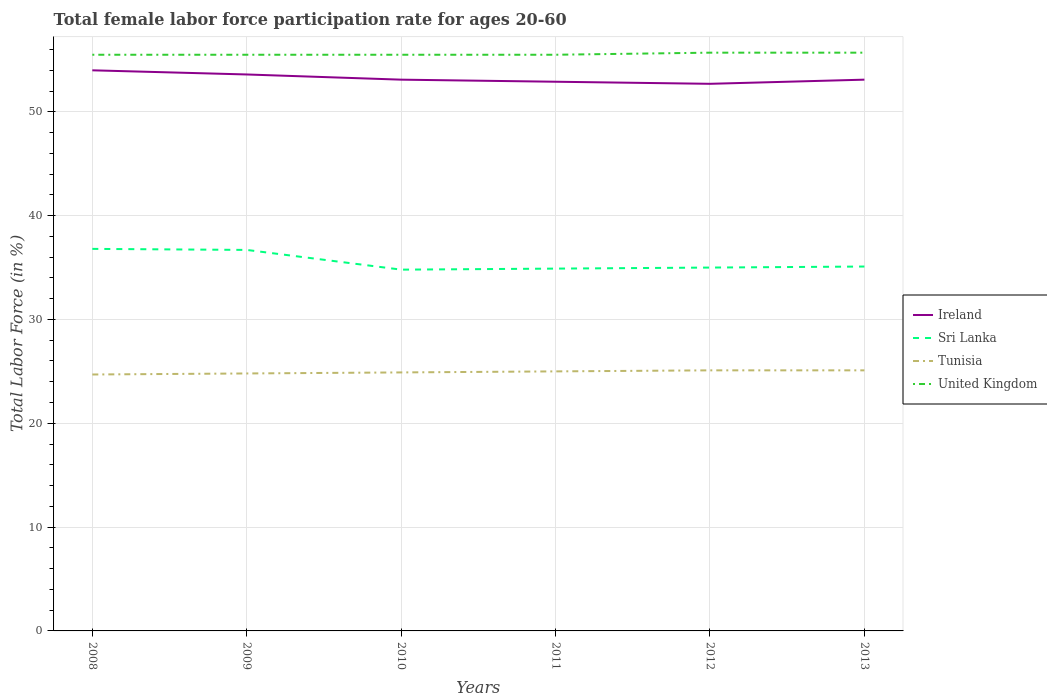Is the number of lines equal to the number of legend labels?
Your response must be concise. Yes. Across all years, what is the maximum female labor force participation rate in Ireland?
Give a very brief answer. 52.7. What is the total female labor force participation rate in Tunisia in the graph?
Offer a very short reply. -0.2. What is the difference between the highest and the second highest female labor force participation rate in Ireland?
Provide a short and direct response. 1.3. What is the difference between the highest and the lowest female labor force participation rate in Tunisia?
Offer a very short reply. 3. Is the female labor force participation rate in United Kingdom strictly greater than the female labor force participation rate in Sri Lanka over the years?
Provide a short and direct response. No. How many years are there in the graph?
Provide a short and direct response. 6. Where does the legend appear in the graph?
Your response must be concise. Center right. What is the title of the graph?
Your answer should be very brief. Total female labor force participation rate for ages 20-60. What is the label or title of the Y-axis?
Offer a very short reply. Total Labor Force (in %). What is the Total Labor Force (in %) in Sri Lanka in 2008?
Your answer should be compact. 36.8. What is the Total Labor Force (in %) in Tunisia in 2008?
Make the answer very short. 24.7. What is the Total Labor Force (in %) of United Kingdom in 2008?
Offer a very short reply. 55.5. What is the Total Labor Force (in %) in Ireland in 2009?
Provide a short and direct response. 53.6. What is the Total Labor Force (in %) in Sri Lanka in 2009?
Your response must be concise. 36.7. What is the Total Labor Force (in %) of Tunisia in 2009?
Keep it short and to the point. 24.8. What is the Total Labor Force (in %) in United Kingdom in 2009?
Your answer should be compact. 55.5. What is the Total Labor Force (in %) of Ireland in 2010?
Your response must be concise. 53.1. What is the Total Labor Force (in %) in Sri Lanka in 2010?
Your answer should be compact. 34.8. What is the Total Labor Force (in %) in Tunisia in 2010?
Make the answer very short. 24.9. What is the Total Labor Force (in %) of United Kingdom in 2010?
Provide a succinct answer. 55.5. What is the Total Labor Force (in %) in Ireland in 2011?
Provide a succinct answer. 52.9. What is the Total Labor Force (in %) in Sri Lanka in 2011?
Give a very brief answer. 34.9. What is the Total Labor Force (in %) in United Kingdom in 2011?
Offer a terse response. 55.5. What is the Total Labor Force (in %) in Ireland in 2012?
Your answer should be compact. 52.7. What is the Total Labor Force (in %) of Tunisia in 2012?
Offer a very short reply. 25.1. What is the Total Labor Force (in %) in United Kingdom in 2012?
Ensure brevity in your answer.  55.7. What is the Total Labor Force (in %) of Ireland in 2013?
Your answer should be compact. 53.1. What is the Total Labor Force (in %) in Sri Lanka in 2013?
Your answer should be compact. 35.1. What is the Total Labor Force (in %) in Tunisia in 2013?
Make the answer very short. 25.1. What is the Total Labor Force (in %) of United Kingdom in 2013?
Offer a very short reply. 55.7. Across all years, what is the maximum Total Labor Force (in %) in Sri Lanka?
Your answer should be very brief. 36.8. Across all years, what is the maximum Total Labor Force (in %) in Tunisia?
Your response must be concise. 25.1. Across all years, what is the maximum Total Labor Force (in %) in United Kingdom?
Provide a short and direct response. 55.7. Across all years, what is the minimum Total Labor Force (in %) of Ireland?
Provide a short and direct response. 52.7. Across all years, what is the minimum Total Labor Force (in %) of Sri Lanka?
Ensure brevity in your answer.  34.8. Across all years, what is the minimum Total Labor Force (in %) of Tunisia?
Ensure brevity in your answer.  24.7. Across all years, what is the minimum Total Labor Force (in %) in United Kingdom?
Ensure brevity in your answer.  55.5. What is the total Total Labor Force (in %) of Ireland in the graph?
Provide a succinct answer. 319.4. What is the total Total Labor Force (in %) of Sri Lanka in the graph?
Make the answer very short. 213.3. What is the total Total Labor Force (in %) in Tunisia in the graph?
Provide a succinct answer. 149.6. What is the total Total Labor Force (in %) in United Kingdom in the graph?
Provide a short and direct response. 333.4. What is the difference between the Total Labor Force (in %) in Sri Lanka in 2008 and that in 2009?
Your answer should be very brief. 0.1. What is the difference between the Total Labor Force (in %) in Ireland in 2008 and that in 2010?
Offer a very short reply. 0.9. What is the difference between the Total Labor Force (in %) in Tunisia in 2008 and that in 2010?
Your response must be concise. -0.2. What is the difference between the Total Labor Force (in %) of Ireland in 2008 and that in 2011?
Give a very brief answer. 1.1. What is the difference between the Total Labor Force (in %) in Sri Lanka in 2008 and that in 2011?
Provide a short and direct response. 1.9. What is the difference between the Total Labor Force (in %) in United Kingdom in 2008 and that in 2011?
Offer a terse response. 0. What is the difference between the Total Labor Force (in %) in Ireland in 2008 and that in 2012?
Offer a terse response. 1.3. What is the difference between the Total Labor Force (in %) in Tunisia in 2008 and that in 2013?
Provide a short and direct response. -0.4. What is the difference between the Total Labor Force (in %) of Ireland in 2009 and that in 2010?
Keep it short and to the point. 0.5. What is the difference between the Total Labor Force (in %) in Sri Lanka in 2009 and that in 2011?
Offer a terse response. 1.8. What is the difference between the Total Labor Force (in %) in United Kingdom in 2009 and that in 2011?
Keep it short and to the point. 0. What is the difference between the Total Labor Force (in %) of Ireland in 2009 and that in 2012?
Your answer should be very brief. 0.9. What is the difference between the Total Labor Force (in %) in United Kingdom in 2009 and that in 2012?
Give a very brief answer. -0.2. What is the difference between the Total Labor Force (in %) in Tunisia in 2009 and that in 2013?
Provide a short and direct response. -0.3. What is the difference between the Total Labor Force (in %) in United Kingdom in 2009 and that in 2013?
Offer a very short reply. -0.2. What is the difference between the Total Labor Force (in %) of Ireland in 2010 and that in 2011?
Make the answer very short. 0.2. What is the difference between the Total Labor Force (in %) of United Kingdom in 2010 and that in 2011?
Keep it short and to the point. 0. What is the difference between the Total Labor Force (in %) of Sri Lanka in 2010 and that in 2012?
Your answer should be compact. -0.2. What is the difference between the Total Labor Force (in %) in Tunisia in 2010 and that in 2012?
Offer a very short reply. -0.2. What is the difference between the Total Labor Force (in %) of Ireland in 2010 and that in 2013?
Keep it short and to the point. 0. What is the difference between the Total Labor Force (in %) of Sri Lanka in 2010 and that in 2013?
Give a very brief answer. -0.3. What is the difference between the Total Labor Force (in %) of United Kingdom in 2010 and that in 2013?
Make the answer very short. -0.2. What is the difference between the Total Labor Force (in %) in Ireland in 2011 and that in 2012?
Provide a short and direct response. 0.2. What is the difference between the Total Labor Force (in %) of Ireland in 2011 and that in 2013?
Keep it short and to the point. -0.2. What is the difference between the Total Labor Force (in %) of United Kingdom in 2011 and that in 2013?
Make the answer very short. -0.2. What is the difference between the Total Labor Force (in %) of Ireland in 2012 and that in 2013?
Keep it short and to the point. -0.4. What is the difference between the Total Labor Force (in %) in Tunisia in 2012 and that in 2013?
Offer a very short reply. 0. What is the difference between the Total Labor Force (in %) of Ireland in 2008 and the Total Labor Force (in %) of Tunisia in 2009?
Ensure brevity in your answer.  29.2. What is the difference between the Total Labor Force (in %) in Ireland in 2008 and the Total Labor Force (in %) in United Kingdom in 2009?
Your response must be concise. -1.5. What is the difference between the Total Labor Force (in %) in Sri Lanka in 2008 and the Total Labor Force (in %) in Tunisia in 2009?
Give a very brief answer. 12. What is the difference between the Total Labor Force (in %) in Sri Lanka in 2008 and the Total Labor Force (in %) in United Kingdom in 2009?
Your answer should be compact. -18.7. What is the difference between the Total Labor Force (in %) in Tunisia in 2008 and the Total Labor Force (in %) in United Kingdom in 2009?
Keep it short and to the point. -30.8. What is the difference between the Total Labor Force (in %) in Ireland in 2008 and the Total Labor Force (in %) in Sri Lanka in 2010?
Provide a succinct answer. 19.2. What is the difference between the Total Labor Force (in %) in Ireland in 2008 and the Total Labor Force (in %) in Tunisia in 2010?
Provide a short and direct response. 29.1. What is the difference between the Total Labor Force (in %) of Sri Lanka in 2008 and the Total Labor Force (in %) of United Kingdom in 2010?
Offer a very short reply. -18.7. What is the difference between the Total Labor Force (in %) of Tunisia in 2008 and the Total Labor Force (in %) of United Kingdom in 2010?
Provide a short and direct response. -30.8. What is the difference between the Total Labor Force (in %) of Ireland in 2008 and the Total Labor Force (in %) of Sri Lanka in 2011?
Your response must be concise. 19.1. What is the difference between the Total Labor Force (in %) of Ireland in 2008 and the Total Labor Force (in %) of United Kingdom in 2011?
Offer a very short reply. -1.5. What is the difference between the Total Labor Force (in %) of Sri Lanka in 2008 and the Total Labor Force (in %) of Tunisia in 2011?
Keep it short and to the point. 11.8. What is the difference between the Total Labor Force (in %) of Sri Lanka in 2008 and the Total Labor Force (in %) of United Kingdom in 2011?
Provide a short and direct response. -18.7. What is the difference between the Total Labor Force (in %) in Tunisia in 2008 and the Total Labor Force (in %) in United Kingdom in 2011?
Provide a succinct answer. -30.8. What is the difference between the Total Labor Force (in %) in Ireland in 2008 and the Total Labor Force (in %) in Sri Lanka in 2012?
Keep it short and to the point. 19. What is the difference between the Total Labor Force (in %) of Ireland in 2008 and the Total Labor Force (in %) of Tunisia in 2012?
Provide a short and direct response. 28.9. What is the difference between the Total Labor Force (in %) of Ireland in 2008 and the Total Labor Force (in %) of United Kingdom in 2012?
Make the answer very short. -1.7. What is the difference between the Total Labor Force (in %) in Sri Lanka in 2008 and the Total Labor Force (in %) in Tunisia in 2012?
Make the answer very short. 11.7. What is the difference between the Total Labor Force (in %) of Sri Lanka in 2008 and the Total Labor Force (in %) of United Kingdom in 2012?
Your answer should be very brief. -18.9. What is the difference between the Total Labor Force (in %) of Tunisia in 2008 and the Total Labor Force (in %) of United Kingdom in 2012?
Provide a succinct answer. -31. What is the difference between the Total Labor Force (in %) in Ireland in 2008 and the Total Labor Force (in %) in Sri Lanka in 2013?
Keep it short and to the point. 18.9. What is the difference between the Total Labor Force (in %) of Ireland in 2008 and the Total Labor Force (in %) of Tunisia in 2013?
Keep it short and to the point. 28.9. What is the difference between the Total Labor Force (in %) in Sri Lanka in 2008 and the Total Labor Force (in %) in Tunisia in 2013?
Offer a very short reply. 11.7. What is the difference between the Total Labor Force (in %) of Sri Lanka in 2008 and the Total Labor Force (in %) of United Kingdom in 2013?
Your response must be concise. -18.9. What is the difference between the Total Labor Force (in %) in Tunisia in 2008 and the Total Labor Force (in %) in United Kingdom in 2013?
Your response must be concise. -31. What is the difference between the Total Labor Force (in %) of Ireland in 2009 and the Total Labor Force (in %) of Sri Lanka in 2010?
Make the answer very short. 18.8. What is the difference between the Total Labor Force (in %) of Ireland in 2009 and the Total Labor Force (in %) of Tunisia in 2010?
Make the answer very short. 28.7. What is the difference between the Total Labor Force (in %) of Sri Lanka in 2009 and the Total Labor Force (in %) of United Kingdom in 2010?
Ensure brevity in your answer.  -18.8. What is the difference between the Total Labor Force (in %) in Tunisia in 2009 and the Total Labor Force (in %) in United Kingdom in 2010?
Make the answer very short. -30.7. What is the difference between the Total Labor Force (in %) in Ireland in 2009 and the Total Labor Force (in %) in Tunisia in 2011?
Ensure brevity in your answer.  28.6. What is the difference between the Total Labor Force (in %) in Sri Lanka in 2009 and the Total Labor Force (in %) in Tunisia in 2011?
Your answer should be very brief. 11.7. What is the difference between the Total Labor Force (in %) of Sri Lanka in 2009 and the Total Labor Force (in %) of United Kingdom in 2011?
Ensure brevity in your answer.  -18.8. What is the difference between the Total Labor Force (in %) in Tunisia in 2009 and the Total Labor Force (in %) in United Kingdom in 2011?
Give a very brief answer. -30.7. What is the difference between the Total Labor Force (in %) in Ireland in 2009 and the Total Labor Force (in %) in Sri Lanka in 2012?
Provide a short and direct response. 18.6. What is the difference between the Total Labor Force (in %) of Ireland in 2009 and the Total Labor Force (in %) of Tunisia in 2012?
Provide a succinct answer. 28.5. What is the difference between the Total Labor Force (in %) of Ireland in 2009 and the Total Labor Force (in %) of United Kingdom in 2012?
Offer a terse response. -2.1. What is the difference between the Total Labor Force (in %) of Sri Lanka in 2009 and the Total Labor Force (in %) of Tunisia in 2012?
Your response must be concise. 11.6. What is the difference between the Total Labor Force (in %) in Sri Lanka in 2009 and the Total Labor Force (in %) in United Kingdom in 2012?
Ensure brevity in your answer.  -19. What is the difference between the Total Labor Force (in %) in Tunisia in 2009 and the Total Labor Force (in %) in United Kingdom in 2012?
Provide a short and direct response. -30.9. What is the difference between the Total Labor Force (in %) in Ireland in 2009 and the Total Labor Force (in %) in Sri Lanka in 2013?
Make the answer very short. 18.5. What is the difference between the Total Labor Force (in %) in Sri Lanka in 2009 and the Total Labor Force (in %) in United Kingdom in 2013?
Offer a terse response. -19. What is the difference between the Total Labor Force (in %) in Tunisia in 2009 and the Total Labor Force (in %) in United Kingdom in 2013?
Offer a terse response. -30.9. What is the difference between the Total Labor Force (in %) of Ireland in 2010 and the Total Labor Force (in %) of Tunisia in 2011?
Provide a short and direct response. 28.1. What is the difference between the Total Labor Force (in %) of Sri Lanka in 2010 and the Total Labor Force (in %) of United Kingdom in 2011?
Your answer should be compact. -20.7. What is the difference between the Total Labor Force (in %) of Tunisia in 2010 and the Total Labor Force (in %) of United Kingdom in 2011?
Make the answer very short. -30.6. What is the difference between the Total Labor Force (in %) of Sri Lanka in 2010 and the Total Labor Force (in %) of United Kingdom in 2012?
Provide a short and direct response. -20.9. What is the difference between the Total Labor Force (in %) in Tunisia in 2010 and the Total Labor Force (in %) in United Kingdom in 2012?
Provide a short and direct response. -30.8. What is the difference between the Total Labor Force (in %) of Ireland in 2010 and the Total Labor Force (in %) of Sri Lanka in 2013?
Make the answer very short. 18. What is the difference between the Total Labor Force (in %) of Ireland in 2010 and the Total Labor Force (in %) of Tunisia in 2013?
Ensure brevity in your answer.  28. What is the difference between the Total Labor Force (in %) of Sri Lanka in 2010 and the Total Labor Force (in %) of United Kingdom in 2013?
Make the answer very short. -20.9. What is the difference between the Total Labor Force (in %) of Tunisia in 2010 and the Total Labor Force (in %) of United Kingdom in 2013?
Ensure brevity in your answer.  -30.8. What is the difference between the Total Labor Force (in %) of Ireland in 2011 and the Total Labor Force (in %) of Sri Lanka in 2012?
Provide a succinct answer. 17.9. What is the difference between the Total Labor Force (in %) of Ireland in 2011 and the Total Labor Force (in %) of Tunisia in 2012?
Provide a succinct answer. 27.8. What is the difference between the Total Labor Force (in %) in Ireland in 2011 and the Total Labor Force (in %) in United Kingdom in 2012?
Give a very brief answer. -2.8. What is the difference between the Total Labor Force (in %) in Sri Lanka in 2011 and the Total Labor Force (in %) in Tunisia in 2012?
Offer a terse response. 9.8. What is the difference between the Total Labor Force (in %) in Sri Lanka in 2011 and the Total Labor Force (in %) in United Kingdom in 2012?
Make the answer very short. -20.8. What is the difference between the Total Labor Force (in %) in Tunisia in 2011 and the Total Labor Force (in %) in United Kingdom in 2012?
Make the answer very short. -30.7. What is the difference between the Total Labor Force (in %) of Ireland in 2011 and the Total Labor Force (in %) of Tunisia in 2013?
Offer a terse response. 27.8. What is the difference between the Total Labor Force (in %) of Ireland in 2011 and the Total Labor Force (in %) of United Kingdom in 2013?
Keep it short and to the point. -2.8. What is the difference between the Total Labor Force (in %) of Sri Lanka in 2011 and the Total Labor Force (in %) of United Kingdom in 2013?
Make the answer very short. -20.8. What is the difference between the Total Labor Force (in %) of Tunisia in 2011 and the Total Labor Force (in %) of United Kingdom in 2013?
Offer a terse response. -30.7. What is the difference between the Total Labor Force (in %) of Ireland in 2012 and the Total Labor Force (in %) of Sri Lanka in 2013?
Offer a very short reply. 17.6. What is the difference between the Total Labor Force (in %) of Ireland in 2012 and the Total Labor Force (in %) of Tunisia in 2013?
Provide a succinct answer. 27.6. What is the difference between the Total Labor Force (in %) of Ireland in 2012 and the Total Labor Force (in %) of United Kingdom in 2013?
Offer a very short reply. -3. What is the difference between the Total Labor Force (in %) of Sri Lanka in 2012 and the Total Labor Force (in %) of United Kingdom in 2013?
Make the answer very short. -20.7. What is the difference between the Total Labor Force (in %) in Tunisia in 2012 and the Total Labor Force (in %) in United Kingdom in 2013?
Ensure brevity in your answer.  -30.6. What is the average Total Labor Force (in %) in Ireland per year?
Offer a terse response. 53.23. What is the average Total Labor Force (in %) in Sri Lanka per year?
Give a very brief answer. 35.55. What is the average Total Labor Force (in %) in Tunisia per year?
Provide a short and direct response. 24.93. What is the average Total Labor Force (in %) of United Kingdom per year?
Provide a succinct answer. 55.57. In the year 2008, what is the difference between the Total Labor Force (in %) of Ireland and Total Labor Force (in %) of Tunisia?
Keep it short and to the point. 29.3. In the year 2008, what is the difference between the Total Labor Force (in %) in Sri Lanka and Total Labor Force (in %) in United Kingdom?
Provide a short and direct response. -18.7. In the year 2008, what is the difference between the Total Labor Force (in %) in Tunisia and Total Labor Force (in %) in United Kingdom?
Provide a short and direct response. -30.8. In the year 2009, what is the difference between the Total Labor Force (in %) of Ireland and Total Labor Force (in %) of Sri Lanka?
Provide a succinct answer. 16.9. In the year 2009, what is the difference between the Total Labor Force (in %) in Ireland and Total Labor Force (in %) in Tunisia?
Your answer should be very brief. 28.8. In the year 2009, what is the difference between the Total Labor Force (in %) in Sri Lanka and Total Labor Force (in %) in Tunisia?
Offer a very short reply. 11.9. In the year 2009, what is the difference between the Total Labor Force (in %) in Sri Lanka and Total Labor Force (in %) in United Kingdom?
Provide a succinct answer. -18.8. In the year 2009, what is the difference between the Total Labor Force (in %) in Tunisia and Total Labor Force (in %) in United Kingdom?
Your answer should be compact. -30.7. In the year 2010, what is the difference between the Total Labor Force (in %) of Ireland and Total Labor Force (in %) of Tunisia?
Your answer should be very brief. 28.2. In the year 2010, what is the difference between the Total Labor Force (in %) of Sri Lanka and Total Labor Force (in %) of Tunisia?
Your answer should be very brief. 9.9. In the year 2010, what is the difference between the Total Labor Force (in %) of Sri Lanka and Total Labor Force (in %) of United Kingdom?
Your response must be concise. -20.7. In the year 2010, what is the difference between the Total Labor Force (in %) of Tunisia and Total Labor Force (in %) of United Kingdom?
Provide a succinct answer. -30.6. In the year 2011, what is the difference between the Total Labor Force (in %) of Ireland and Total Labor Force (in %) of Sri Lanka?
Your answer should be compact. 18. In the year 2011, what is the difference between the Total Labor Force (in %) in Ireland and Total Labor Force (in %) in Tunisia?
Your answer should be very brief. 27.9. In the year 2011, what is the difference between the Total Labor Force (in %) of Sri Lanka and Total Labor Force (in %) of United Kingdom?
Make the answer very short. -20.6. In the year 2011, what is the difference between the Total Labor Force (in %) in Tunisia and Total Labor Force (in %) in United Kingdom?
Keep it short and to the point. -30.5. In the year 2012, what is the difference between the Total Labor Force (in %) of Ireland and Total Labor Force (in %) of Tunisia?
Provide a short and direct response. 27.6. In the year 2012, what is the difference between the Total Labor Force (in %) in Ireland and Total Labor Force (in %) in United Kingdom?
Give a very brief answer. -3. In the year 2012, what is the difference between the Total Labor Force (in %) of Sri Lanka and Total Labor Force (in %) of Tunisia?
Ensure brevity in your answer.  9.9. In the year 2012, what is the difference between the Total Labor Force (in %) in Sri Lanka and Total Labor Force (in %) in United Kingdom?
Your answer should be compact. -20.7. In the year 2012, what is the difference between the Total Labor Force (in %) in Tunisia and Total Labor Force (in %) in United Kingdom?
Give a very brief answer. -30.6. In the year 2013, what is the difference between the Total Labor Force (in %) of Ireland and Total Labor Force (in %) of Sri Lanka?
Your response must be concise. 18. In the year 2013, what is the difference between the Total Labor Force (in %) in Ireland and Total Labor Force (in %) in Tunisia?
Keep it short and to the point. 28. In the year 2013, what is the difference between the Total Labor Force (in %) of Sri Lanka and Total Labor Force (in %) of United Kingdom?
Provide a succinct answer. -20.6. In the year 2013, what is the difference between the Total Labor Force (in %) of Tunisia and Total Labor Force (in %) of United Kingdom?
Give a very brief answer. -30.6. What is the ratio of the Total Labor Force (in %) of Ireland in 2008 to that in 2009?
Keep it short and to the point. 1.01. What is the ratio of the Total Labor Force (in %) of Sri Lanka in 2008 to that in 2009?
Give a very brief answer. 1. What is the ratio of the Total Labor Force (in %) in Tunisia in 2008 to that in 2009?
Give a very brief answer. 1. What is the ratio of the Total Labor Force (in %) in United Kingdom in 2008 to that in 2009?
Keep it short and to the point. 1. What is the ratio of the Total Labor Force (in %) in Ireland in 2008 to that in 2010?
Offer a very short reply. 1.02. What is the ratio of the Total Labor Force (in %) of Sri Lanka in 2008 to that in 2010?
Your answer should be compact. 1.06. What is the ratio of the Total Labor Force (in %) of Ireland in 2008 to that in 2011?
Keep it short and to the point. 1.02. What is the ratio of the Total Labor Force (in %) of Sri Lanka in 2008 to that in 2011?
Ensure brevity in your answer.  1.05. What is the ratio of the Total Labor Force (in %) in United Kingdom in 2008 to that in 2011?
Offer a terse response. 1. What is the ratio of the Total Labor Force (in %) in Ireland in 2008 to that in 2012?
Your answer should be very brief. 1.02. What is the ratio of the Total Labor Force (in %) in Sri Lanka in 2008 to that in 2012?
Ensure brevity in your answer.  1.05. What is the ratio of the Total Labor Force (in %) in Tunisia in 2008 to that in 2012?
Your response must be concise. 0.98. What is the ratio of the Total Labor Force (in %) in Ireland in 2008 to that in 2013?
Provide a short and direct response. 1.02. What is the ratio of the Total Labor Force (in %) of Sri Lanka in 2008 to that in 2013?
Your answer should be compact. 1.05. What is the ratio of the Total Labor Force (in %) in Tunisia in 2008 to that in 2013?
Keep it short and to the point. 0.98. What is the ratio of the Total Labor Force (in %) in United Kingdom in 2008 to that in 2013?
Offer a very short reply. 1. What is the ratio of the Total Labor Force (in %) of Ireland in 2009 to that in 2010?
Your answer should be very brief. 1.01. What is the ratio of the Total Labor Force (in %) of Sri Lanka in 2009 to that in 2010?
Your answer should be compact. 1.05. What is the ratio of the Total Labor Force (in %) of Ireland in 2009 to that in 2011?
Your response must be concise. 1.01. What is the ratio of the Total Labor Force (in %) of Sri Lanka in 2009 to that in 2011?
Offer a very short reply. 1.05. What is the ratio of the Total Labor Force (in %) in United Kingdom in 2009 to that in 2011?
Ensure brevity in your answer.  1. What is the ratio of the Total Labor Force (in %) of Ireland in 2009 to that in 2012?
Provide a short and direct response. 1.02. What is the ratio of the Total Labor Force (in %) of Sri Lanka in 2009 to that in 2012?
Your answer should be very brief. 1.05. What is the ratio of the Total Labor Force (in %) in Ireland in 2009 to that in 2013?
Ensure brevity in your answer.  1.01. What is the ratio of the Total Labor Force (in %) of Sri Lanka in 2009 to that in 2013?
Give a very brief answer. 1.05. What is the ratio of the Total Labor Force (in %) of Tunisia in 2009 to that in 2013?
Your answer should be compact. 0.99. What is the ratio of the Total Labor Force (in %) in United Kingdom in 2009 to that in 2013?
Provide a succinct answer. 1. What is the ratio of the Total Labor Force (in %) of Ireland in 2010 to that in 2011?
Give a very brief answer. 1. What is the ratio of the Total Labor Force (in %) in Tunisia in 2010 to that in 2011?
Offer a very short reply. 1. What is the ratio of the Total Labor Force (in %) of United Kingdom in 2010 to that in 2011?
Provide a succinct answer. 1. What is the ratio of the Total Labor Force (in %) in Ireland in 2010 to that in 2012?
Your response must be concise. 1.01. What is the ratio of the Total Labor Force (in %) of Sri Lanka in 2010 to that in 2012?
Make the answer very short. 0.99. What is the ratio of the Total Labor Force (in %) in Tunisia in 2010 to that in 2012?
Offer a very short reply. 0.99. What is the ratio of the Total Labor Force (in %) in Tunisia in 2010 to that in 2013?
Your response must be concise. 0.99. What is the ratio of the Total Labor Force (in %) of United Kingdom in 2010 to that in 2013?
Give a very brief answer. 1. What is the ratio of the Total Labor Force (in %) of Tunisia in 2011 to that in 2012?
Offer a terse response. 1. What is the ratio of the Total Labor Force (in %) in Sri Lanka in 2011 to that in 2013?
Provide a short and direct response. 0.99. What is the ratio of the Total Labor Force (in %) of Tunisia in 2011 to that in 2013?
Provide a short and direct response. 1. What is the difference between the highest and the second highest Total Labor Force (in %) in Ireland?
Give a very brief answer. 0.4. What is the difference between the highest and the second highest Total Labor Force (in %) in United Kingdom?
Offer a very short reply. 0. What is the difference between the highest and the lowest Total Labor Force (in %) in Ireland?
Offer a very short reply. 1.3. What is the difference between the highest and the lowest Total Labor Force (in %) in Tunisia?
Provide a succinct answer. 0.4. 